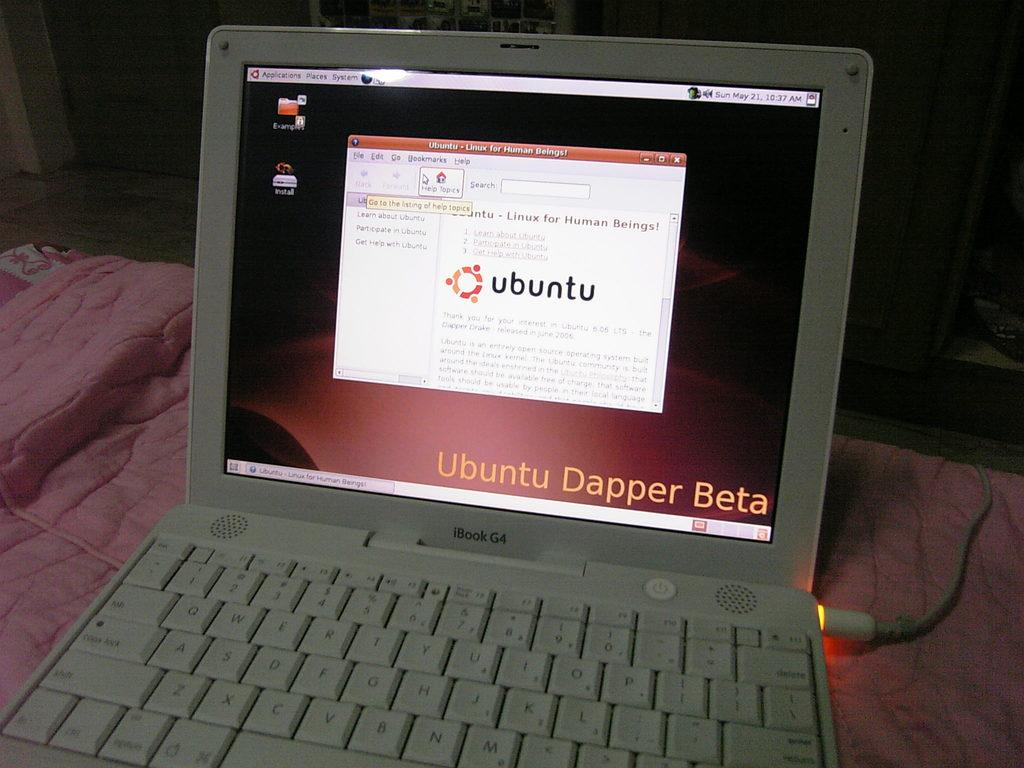<image>
Describe the image concisely. The open laptop has the page for ubuntu set up. 